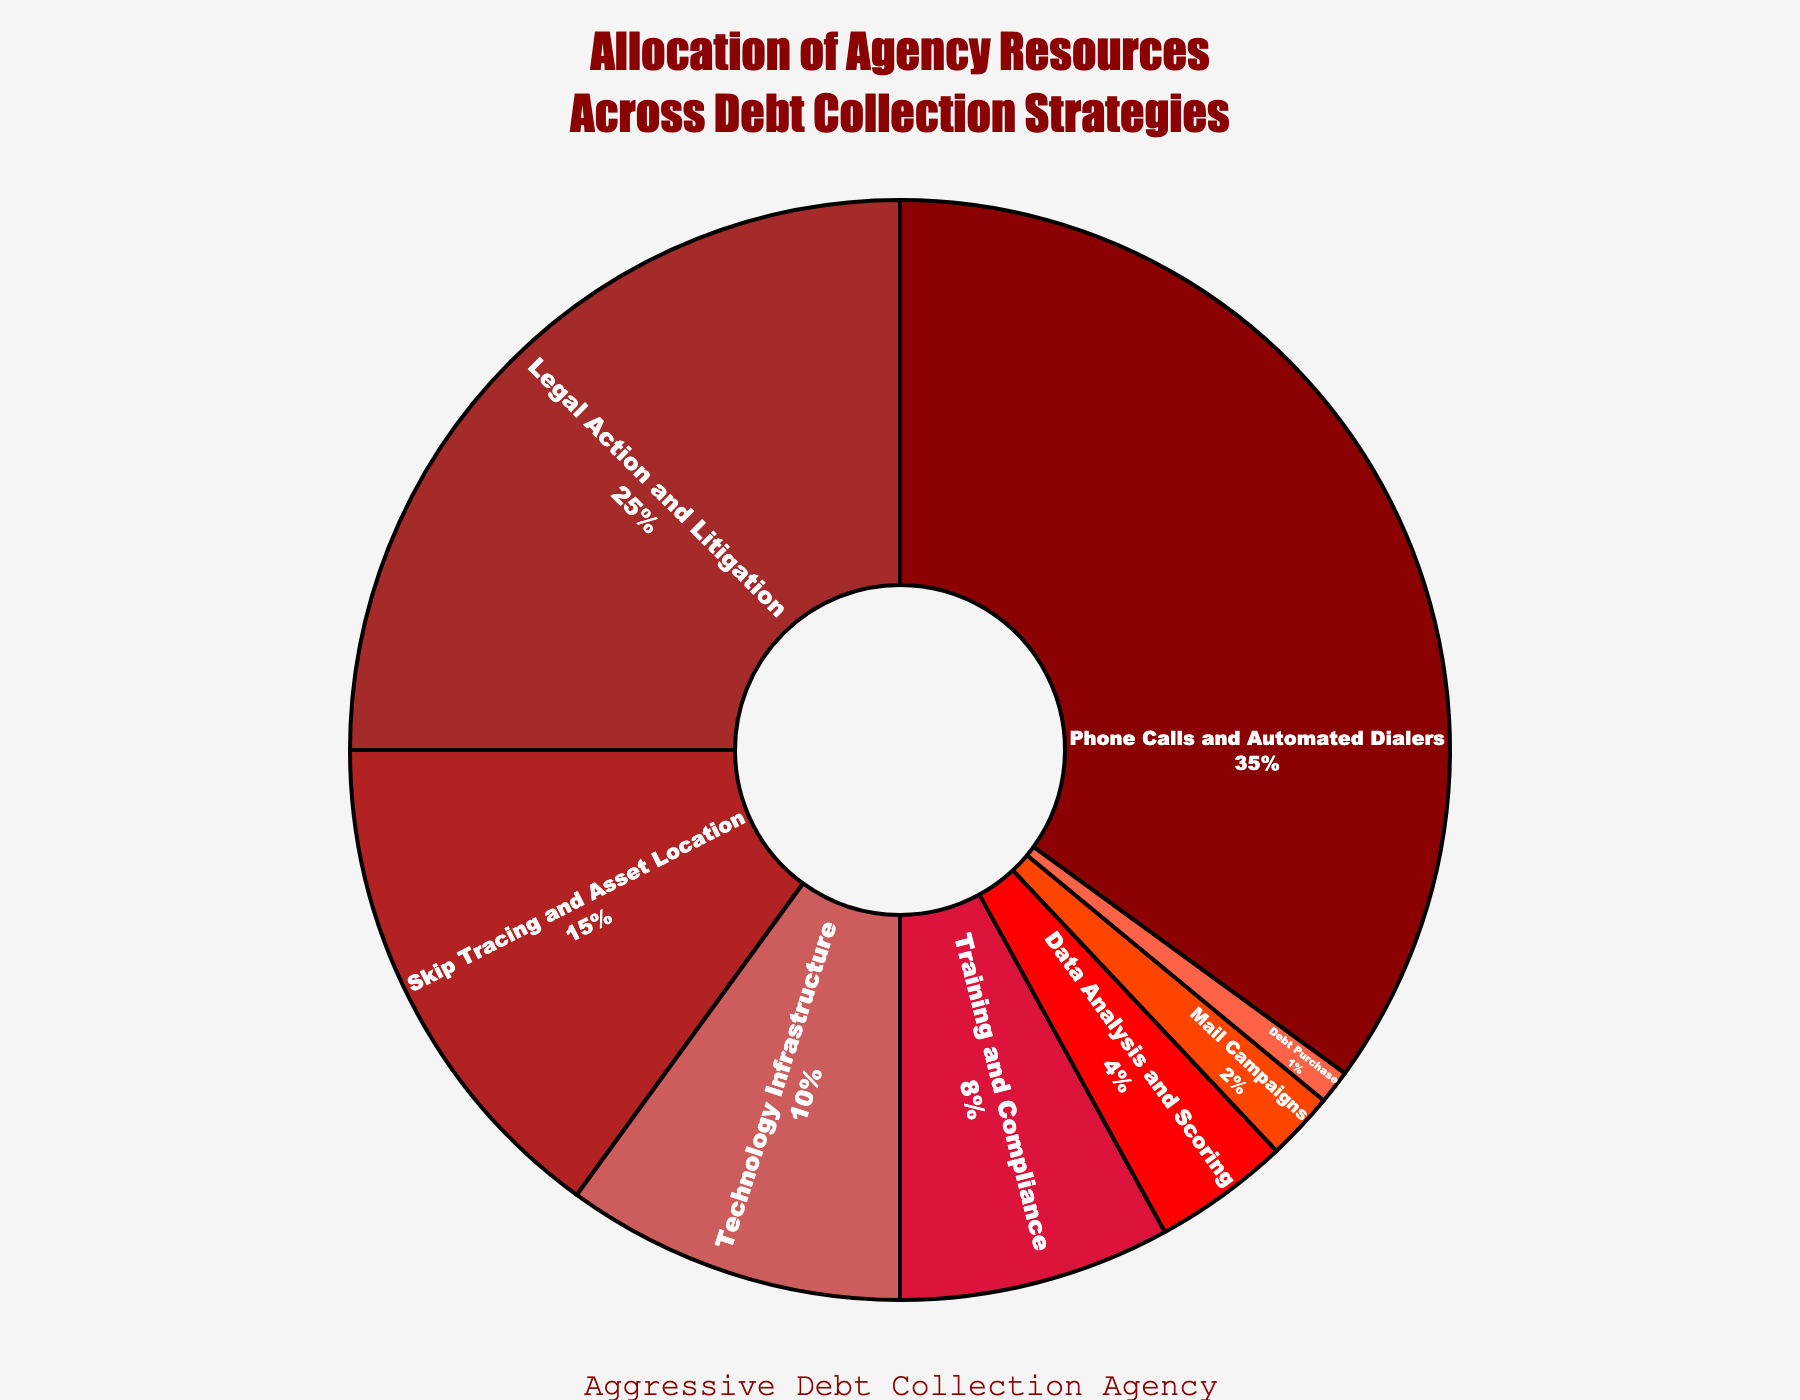Which category consumes the largest percentage of resources? Look at the category with the biggest slice on the pie chart and verify its percentage. The largest percentage is for "Phone Calls and Automated Dialers" which is 35%.
Answer: Phone Calls and Automated Dialers Which category has the smallest allocation? Identify the smallest slice in the pie chart. "Debt Purchase" is the category with the smallest allocation, shown as 1%.
Answer: Debt Purchase What is the combined percentage of the top two resource-consuming categories? Add the percentages of the top two categories: 35% (Phone Calls and Automated Dialers) + 25% (Legal Action and Litigation). The sum is 60%.
Answer: 60% How do Technology Infrastructure and Data Analysis and Scoring together compare percentage-wise to Legal Action and Litigation? Add the percentages of Technology Infrastructure (10%) and Data Analysis and Scoring (4%) to get 14%, then compare it to Legal Action and Litigation, which is 25%. 14% is less than 25%.
Answer: Less What is the total percentage allocated to categories other than Phone Calls and Automated Dialers? Subtract the percentage of Phone Calls and Automated Dialers (35%) from 100%. 100% - 35% = 65%.
Answer: 65% List categories that are allocated less than 10% of resources. Identify slices representing less than 10%. These categories are Training and Compliance (8%), Data Analysis and Scoring (4%), Mail Campaigns (2%), and Debt Purchase (1%).
Answer: Training and Compliance, Data Analysis and Scoring, Mail Campaigns, Debt Purchase Compare the allocation of resources to Skip Tracing and Asset Location versus Training and Compliance. Which one is higher? Skip Tracing and Asset Location has 15%, while Training and Compliance has 8%. Therefore, Skip Tracing and Asset Location has a higher allocation.
Answer: Skip Tracing and Asset Location What's the difference in resource allocation between the highest and lowest categories? Subtract the allocation of the lowest category (Debt Purchase, 1%) from the highest category (Phone Calls and Automated Dialers, 35%). 35% - 1% = 34%.
Answer: 34% How much more is allocated to Legal Action and Litigation compared to Technology Infrastructure? Subtract the percentage of Technology Infrastructure (10%) from Legal Action and Litigation (25%). 25% - 10% = 15%.
Answer: 15% What percentage of resources is allocated to Data Analysis and Scoring and Mail Campaigns combined? Sum the percentages of Data Analysis and Scoring (4%) and Mail Campaigns (2%). 4% + 2% = 6%.
Answer: 6% 